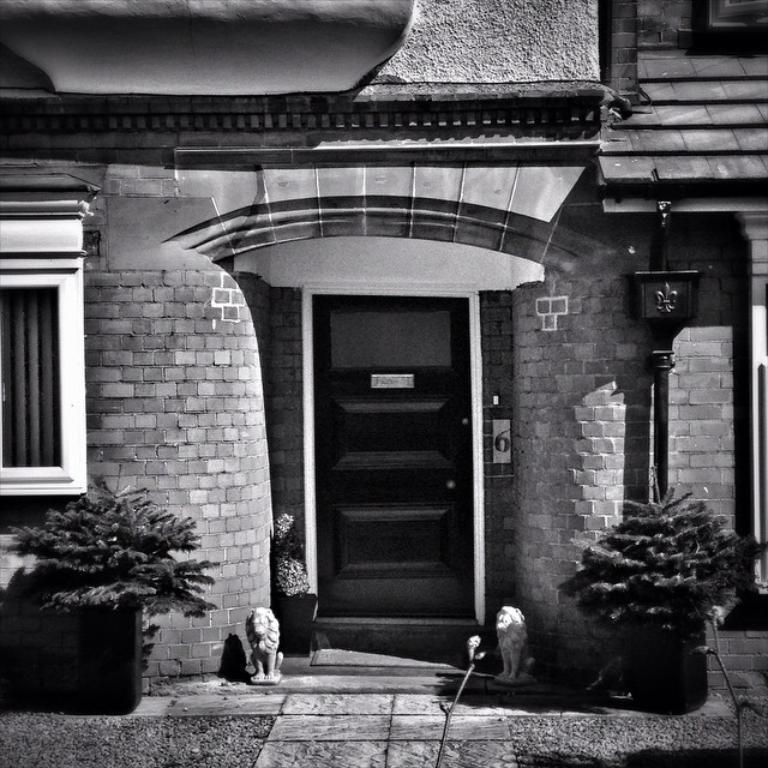Can you describe this image briefly? This is a black and white image. I can see a house with a door and window. In front of the house, there are sculptures, plants in flower pots and a pathway. 